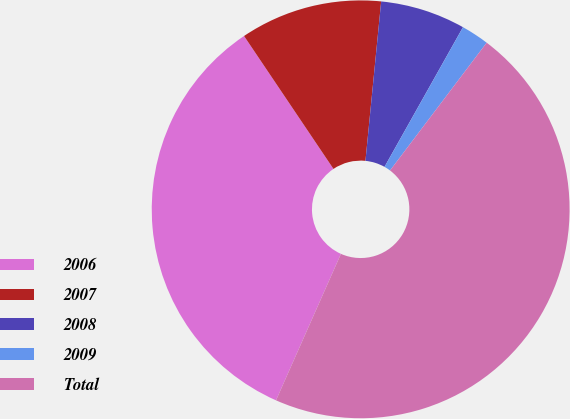<chart> <loc_0><loc_0><loc_500><loc_500><pie_chart><fcel>2006<fcel>2007<fcel>2008<fcel>2009<fcel>Total<nl><fcel>33.93%<fcel>10.99%<fcel>6.58%<fcel>2.16%<fcel>46.33%<nl></chart> 